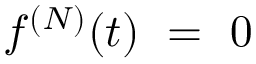<formula> <loc_0><loc_0><loc_500><loc_500>f ^ { ( N ) } ( t ) = 0</formula> 